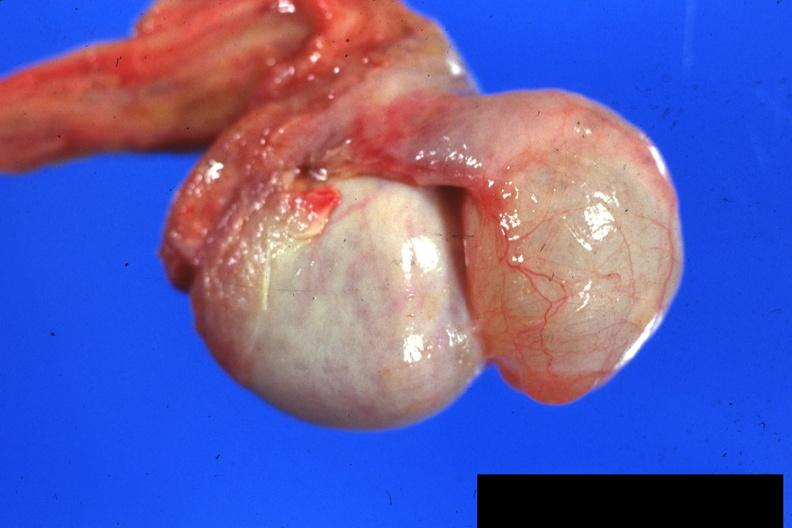what is present?
Answer the question using a single word or phrase. Hydrocele 